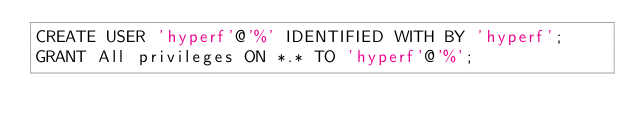<code> <loc_0><loc_0><loc_500><loc_500><_SQL_>CREATE USER 'hyperf'@'%' IDENTIFIED WITH BY 'hyperf';
GRANT All privileges ON *.* TO 'hyperf'@'%';</code> 